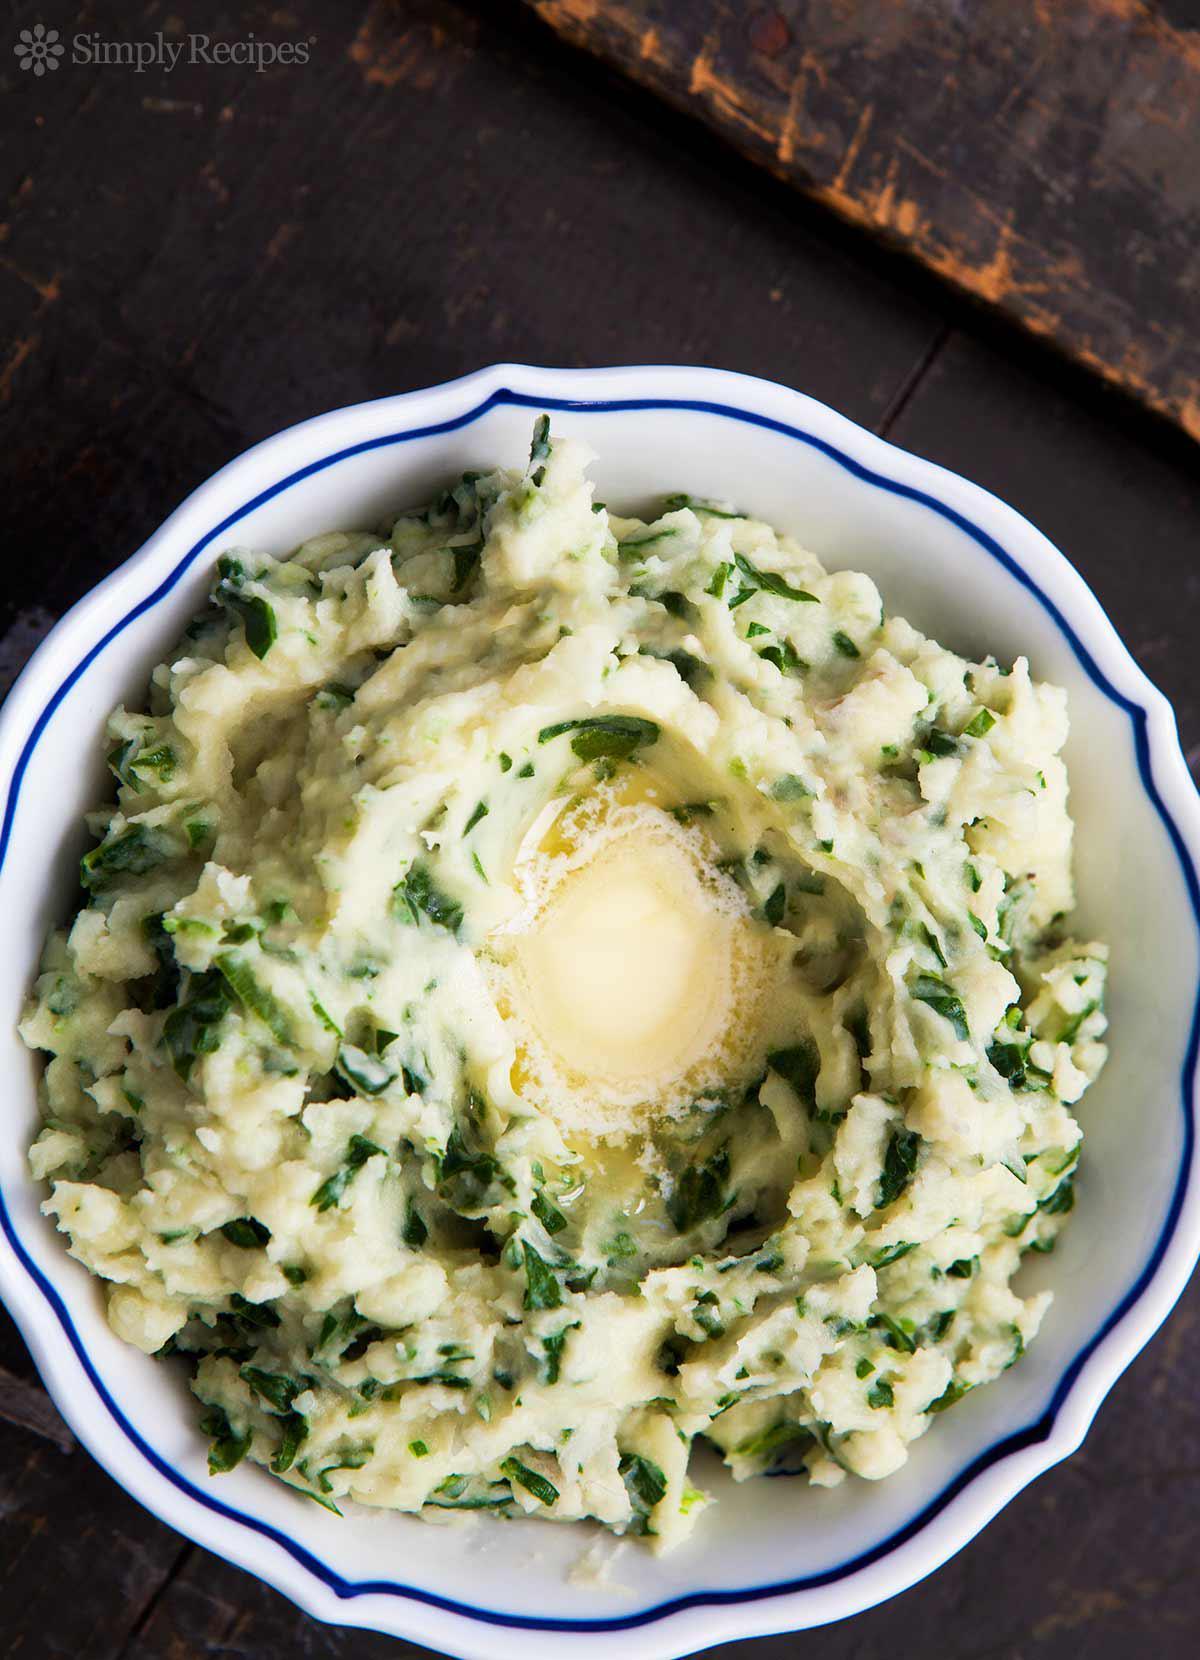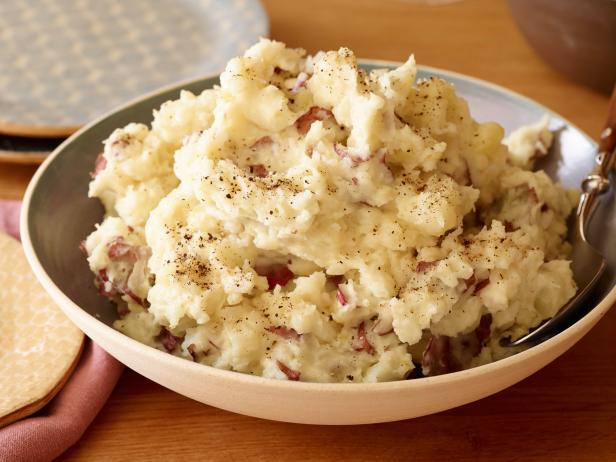The first image is the image on the left, the second image is the image on the right. For the images displayed, is the sentence "Left image shows mashed potatoes in a round bowl with fluted edges." factually correct? Answer yes or no. Yes. The first image is the image on the left, the second image is the image on the right. Given the left and right images, does the statement "The right image contains a spoon, the left image does not, and there is no food outside of the bowl." hold true? Answer yes or no. Yes. 